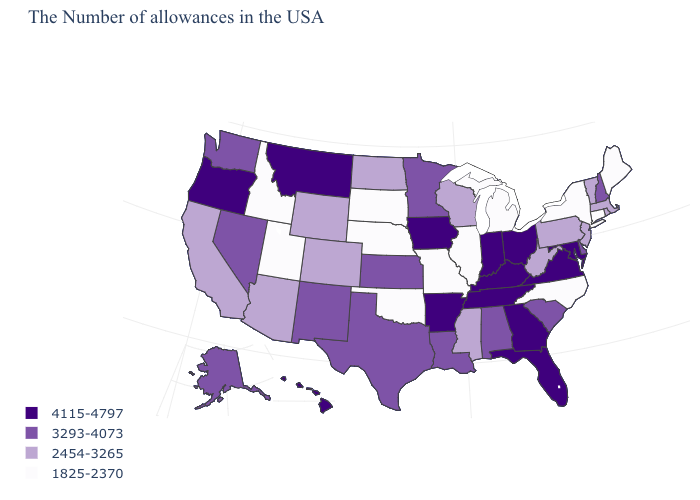What is the value of North Carolina?
Write a very short answer. 1825-2370. What is the value of Utah?
Write a very short answer. 1825-2370. What is the value of Idaho?
Be succinct. 1825-2370. Name the states that have a value in the range 1825-2370?
Write a very short answer. Maine, Connecticut, New York, North Carolina, Michigan, Illinois, Missouri, Nebraska, Oklahoma, South Dakota, Utah, Idaho. Among the states that border West Virginia , does Pennsylvania have the highest value?
Quick response, please. No. What is the value of Delaware?
Write a very short answer. 3293-4073. Among the states that border Maine , which have the highest value?
Answer briefly. New Hampshire. What is the value of Minnesota?
Be succinct. 3293-4073. What is the lowest value in states that border Utah?
Short answer required. 1825-2370. What is the lowest value in states that border Wyoming?
Give a very brief answer. 1825-2370. Which states hav the highest value in the West?
Keep it brief. Montana, Oregon, Hawaii. What is the lowest value in the USA?
Keep it brief. 1825-2370. Does the first symbol in the legend represent the smallest category?
Write a very short answer. No. Does the map have missing data?
Short answer required. No. Among the states that border Colorado , which have the highest value?
Quick response, please. Kansas, New Mexico. 